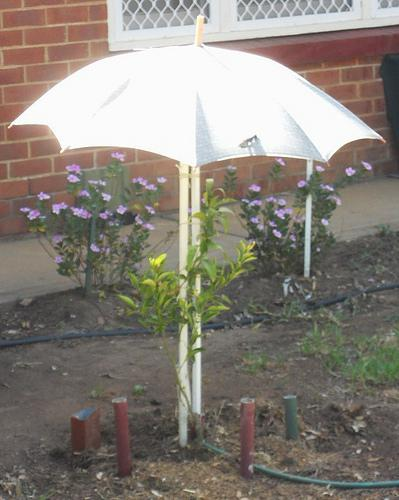Question: why is it there?
Choices:
A. To provide a place to sit.
B. To provide water.
C. To give shade.
D. To provide shelter.
Answer with the letter. Answer: C Question: who put it there?
Choices:
A. A stranger.
B. A person.
C. A traveler.
D. A priest.
Answer with the letter. Answer: B Question: how many umbrellas?
Choices:
A. 2.
B. 1.
C. 3.
D. 10.
Answer with the letter. Answer: B 